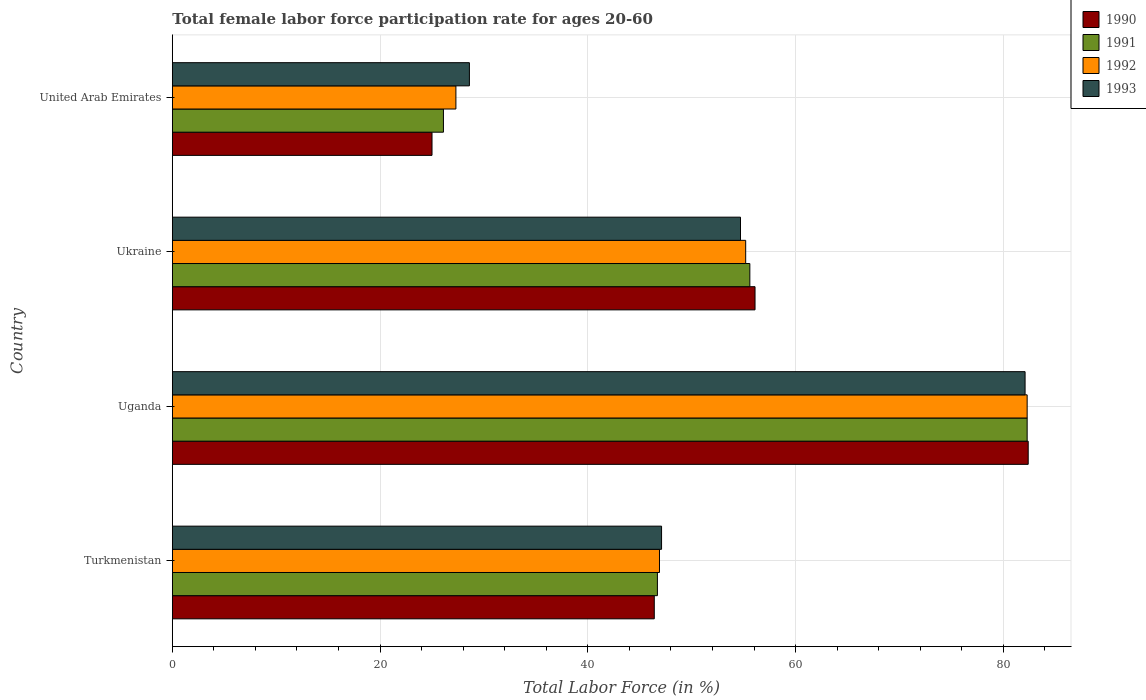How many groups of bars are there?
Make the answer very short. 4. Are the number of bars per tick equal to the number of legend labels?
Keep it short and to the point. Yes. Are the number of bars on each tick of the Y-axis equal?
Keep it short and to the point. Yes. What is the label of the 3rd group of bars from the top?
Offer a terse response. Uganda. What is the female labor force participation rate in 1992 in United Arab Emirates?
Give a very brief answer. 27.3. Across all countries, what is the maximum female labor force participation rate in 1992?
Make the answer very short. 82.3. In which country was the female labor force participation rate in 1991 maximum?
Offer a very short reply. Uganda. In which country was the female labor force participation rate in 1993 minimum?
Make the answer very short. United Arab Emirates. What is the total female labor force participation rate in 1990 in the graph?
Your answer should be very brief. 209.9. What is the difference between the female labor force participation rate in 1990 in Ukraine and that in United Arab Emirates?
Make the answer very short. 31.1. What is the difference between the female labor force participation rate in 1992 in Ukraine and the female labor force participation rate in 1991 in Uganda?
Your answer should be compact. -27.1. What is the average female labor force participation rate in 1993 per country?
Make the answer very short. 53.12. What is the difference between the female labor force participation rate in 1993 and female labor force participation rate in 1990 in Ukraine?
Provide a succinct answer. -1.4. What is the ratio of the female labor force participation rate in 1990 in Turkmenistan to that in Uganda?
Offer a very short reply. 0.56. Is the difference between the female labor force participation rate in 1993 in Ukraine and United Arab Emirates greater than the difference between the female labor force participation rate in 1990 in Ukraine and United Arab Emirates?
Offer a terse response. No. What is the difference between the highest and the second highest female labor force participation rate in 1991?
Offer a terse response. 26.7. What is the difference between the highest and the lowest female labor force participation rate in 1993?
Offer a very short reply. 53.5. In how many countries, is the female labor force participation rate in 1992 greater than the average female labor force participation rate in 1992 taken over all countries?
Offer a very short reply. 2. Is it the case that in every country, the sum of the female labor force participation rate in 1992 and female labor force participation rate in 1991 is greater than the female labor force participation rate in 1993?
Provide a succinct answer. Yes. How many bars are there?
Make the answer very short. 16. Are all the bars in the graph horizontal?
Your answer should be very brief. Yes. How many countries are there in the graph?
Your response must be concise. 4. Are the values on the major ticks of X-axis written in scientific E-notation?
Your answer should be compact. No. Does the graph contain any zero values?
Provide a short and direct response. No. Does the graph contain grids?
Your answer should be compact. Yes. How many legend labels are there?
Offer a terse response. 4. What is the title of the graph?
Your answer should be very brief. Total female labor force participation rate for ages 20-60. What is the label or title of the X-axis?
Provide a succinct answer. Total Labor Force (in %). What is the Total Labor Force (in %) in 1990 in Turkmenistan?
Your answer should be compact. 46.4. What is the Total Labor Force (in %) of 1991 in Turkmenistan?
Your response must be concise. 46.7. What is the Total Labor Force (in %) in 1992 in Turkmenistan?
Your response must be concise. 46.9. What is the Total Labor Force (in %) in 1993 in Turkmenistan?
Provide a succinct answer. 47.1. What is the Total Labor Force (in %) in 1990 in Uganda?
Provide a succinct answer. 82.4. What is the Total Labor Force (in %) of 1991 in Uganda?
Your response must be concise. 82.3. What is the Total Labor Force (in %) of 1992 in Uganda?
Give a very brief answer. 82.3. What is the Total Labor Force (in %) of 1993 in Uganda?
Provide a short and direct response. 82.1. What is the Total Labor Force (in %) of 1990 in Ukraine?
Your answer should be compact. 56.1. What is the Total Labor Force (in %) of 1991 in Ukraine?
Your answer should be very brief. 55.6. What is the Total Labor Force (in %) in 1992 in Ukraine?
Offer a very short reply. 55.2. What is the Total Labor Force (in %) in 1993 in Ukraine?
Ensure brevity in your answer.  54.7. What is the Total Labor Force (in %) of 1990 in United Arab Emirates?
Ensure brevity in your answer.  25. What is the Total Labor Force (in %) of 1991 in United Arab Emirates?
Ensure brevity in your answer.  26.1. What is the Total Labor Force (in %) in 1992 in United Arab Emirates?
Provide a short and direct response. 27.3. What is the Total Labor Force (in %) in 1993 in United Arab Emirates?
Provide a succinct answer. 28.6. Across all countries, what is the maximum Total Labor Force (in %) of 1990?
Keep it short and to the point. 82.4. Across all countries, what is the maximum Total Labor Force (in %) of 1991?
Offer a terse response. 82.3. Across all countries, what is the maximum Total Labor Force (in %) of 1992?
Your answer should be compact. 82.3. Across all countries, what is the maximum Total Labor Force (in %) of 1993?
Provide a succinct answer. 82.1. Across all countries, what is the minimum Total Labor Force (in %) of 1990?
Make the answer very short. 25. Across all countries, what is the minimum Total Labor Force (in %) of 1991?
Make the answer very short. 26.1. Across all countries, what is the minimum Total Labor Force (in %) in 1992?
Make the answer very short. 27.3. Across all countries, what is the minimum Total Labor Force (in %) in 1993?
Offer a very short reply. 28.6. What is the total Total Labor Force (in %) of 1990 in the graph?
Your response must be concise. 209.9. What is the total Total Labor Force (in %) in 1991 in the graph?
Give a very brief answer. 210.7. What is the total Total Labor Force (in %) in 1992 in the graph?
Offer a very short reply. 211.7. What is the total Total Labor Force (in %) of 1993 in the graph?
Your answer should be compact. 212.5. What is the difference between the Total Labor Force (in %) in 1990 in Turkmenistan and that in Uganda?
Keep it short and to the point. -36. What is the difference between the Total Labor Force (in %) of 1991 in Turkmenistan and that in Uganda?
Your answer should be very brief. -35.6. What is the difference between the Total Labor Force (in %) of 1992 in Turkmenistan and that in Uganda?
Your response must be concise. -35.4. What is the difference between the Total Labor Force (in %) in 1993 in Turkmenistan and that in Uganda?
Offer a very short reply. -35. What is the difference between the Total Labor Force (in %) of 1990 in Turkmenistan and that in Ukraine?
Keep it short and to the point. -9.7. What is the difference between the Total Labor Force (in %) in 1992 in Turkmenistan and that in Ukraine?
Ensure brevity in your answer.  -8.3. What is the difference between the Total Labor Force (in %) of 1993 in Turkmenistan and that in Ukraine?
Offer a terse response. -7.6. What is the difference between the Total Labor Force (in %) in 1990 in Turkmenistan and that in United Arab Emirates?
Ensure brevity in your answer.  21.4. What is the difference between the Total Labor Force (in %) in 1991 in Turkmenistan and that in United Arab Emirates?
Offer a very short reply. 20.6. What is the difference between the Total Labor Force (in %) in 1992 in Turkmenistan and that in United Arab Emirates?
Make the answer very short. 19.6. What is the difference between the Total Labor Force (in %) in 1993 in Turkmenistan and that in United Arab Emirates?
Provide a short and direct response. 18.5. What is the difference between the Total Labor Force (in %) of 1990 in Uganda and that in Ukraine?
Your answer should be compact. 26.3. What is the difference between the Total Labor Force (in %) in 1991 in Uganda and that in Ukraine?
Your answer should be compact. 26.7. What is the difference between the Total Labor Force (in %) in 1992 in Uganda and that in Ukraine?
Provide a short and direct response. 27.1. What is the difference between the Total Labor Force (in %) of 1993 in Uganda and that in Ukraine?
Your response must be concise. 27.4. What is the difference between the Total Labor Force (in %) in 1990 in Uganda and that in United Arab Emirates?
Your response must be concise. 57.4. What is the difference between the Total Labor Force (in %) in 1991 in Uganda and that in United Arab Emirates?
Offer a terse response. 56.2. What is the difference between the Total Labor Force (in %) in 1992 in Uganda and that in United Arab Emirates?
Offer a very short reply. 55. What is the difference between the Total Labor Force (in %) in 1993 in Uganda and that in United Arab Emirates?
Offer a terse response. 53.5. What is the difference between the Total Labor Force (in %) of 1990 in Ukraine and that in United Arab Emirates?
Provide a succinct answer. 31.1. What is the difference between the Total Labor Force (in %) in 1991 in Ukraine and that in United Arab Emirates?
Give a very brief answer. 29.5. What is the difference between the Total Labor Force (in %) in 1992 in Ukraine and that in United Arab Emirates?
Ensure brevity in your answer.  27.9. What is the difference between the Total Labor Force (in %) in 1993 in Ukraine and that in United Arab Emirates?
Your response must be concise. 26.1. What is the difference between the Total Labor Force (in %) in 1990 in Turkmenistan and the Total Labor Force (in %) in 1991 in Uganda?
Keep it short and to the point. -35.9. What is the difference between the Total Labor Force (in %) of 1990 in Turkmenistan and the Total Labor Force (in %) of 1992 in Uganda?
Make the answer very short. -35.9. What is the difference between the Total Labor Force (in %) of 1990 in Turkmenistan and the Total Labor Force (in %) of 1993 in Uganda?
Make the answer very short. -35.7. What is the difference between the Total Labor Force (in %) in 1991 in Turkmenistan and the Total Labor Force (in %) in 1992 in Uganda?
Your answer should be very brief. -35.6. What is the difference between the Total Labor Force (in %) in 1991 in Turkmenistan and the Total Labor Force (in %) in 1993 in Uganda?
Keep it short and to the point. -35.4. What is the difference between the Total Labor Force (in %) of 1992 in Turkmenistan and the Total Labor Force (in %) of 1993 in Uganda?
Provide a succinct answer. -35.2. What is the difference between the Total Labor Force (in %) of 1990 in Turkmenistan and the Total Labor Force (in %) of 1991 in Ukraine?
Offer a terse response. -9.2. What is the difference between the Total Labor Force (in %) of 1990 in Turkmenistan and the Total Labor Force (in %) of 1992 in Ukraine?
Your answer should be very brief. -8.8. What is the difference between the Total Labor Force (in %) in 1990 in Turkmenistan and the Total Labor Force (in %) in 1993 in Ukraine?
Offer a terse response. -8.3. What is the difference between the Total Labor Force (in %) of 1991 in Turkmenistan and the Total Labor Force (in %) of 1993 in Ukraine?
Provide a succinct answer. -8. What is the difference between the Total Labor Force (in %) in 1990 in Turkmenistan and the Total Labor Force (in %) in 1991 in United Arab Emirates?
Ensure brevity in your answer.  20.3. What is the difference between the Total Labor Force (in %) of 1990 in Turkmenistan and the Total Labor Force (in %) of 1992 in United Arab Emirates?
Your response must be concise. 19.1. What is the difference between the Total Labor Force (in %) in 1990 in Turkmenistan and the Total Labor Force (in %) in 1993 in United Arab Emirates?
Provide a succinct answer. 17.8. What is the difference between the Total Labor Force (in %) of 1992 in Turkmenistan and the Total Labor Force (in %) of 1993 in United Arab Emirates?
Offer a terse response. 18.3. What is the difference between the Total Labor Force (in %) of 1990 in Uganda and the Total Labor Force (in %) of 1991 in Ukraine?
Your answer should be compact. 26.8. What is the difference between the Total Labor Force (in %) in 1990 in Uganda and the Total Labor Force (in %) in 1992 in Ukraine?
Keep it short and to the point. 27.2. What is the difference between the Total Labor Force (in %) in 1990 in Uganda and the Total Labor Force (in %) in 1993 in Ukraine?
Your answer should be compact. 27.7. What is the difference between the Total Labor Force (in %) in 1991 in Uganda and the Total Labor Force (in %) in 1992 in Ukraine?
Provide a short and direct response. 27.1. What is the difference between the Total Labor Force (in %) in 1991 in Uganda and the Total Labor Force (in %) in 1993 in Ukraine?
Give a very brief answer. 27.6. What is the difference between the Total Labor Force (in %) of 1992 in Uganda and the Total Labor Force (in %) of 1993 in Ukraine?
Provide a succinct answer. 27.6. What is the difference between the Total Labor Force (in %) in 1990 in Uganda and the Total Labor Force (in %) in 1991 in United Arab Emirates?
Give a very brief answer. 56.3. What is the difference between the Total Labor Force (in %) in 1990 in Uganda and the Total Labor Force (in %) in 1992 in United Arab Emirates?
Give a very brief answer. 55.1. What is the difference between the Total Labor Force (in %) in 1990 in Uganda and the Total Labor Force (in %) in 1993 in United Arab Emirates?
Your response must be concise. 53.8. What is the difference between the Total Labor Force (in %) of 1991 in Uganda and the Total Labor Force (in %) of 1993 in United Arab Emirates?
Keep it short and to the point. 53.7. What is the difference between the Total Labor Force (in %) in 1992 in Uganda and the Total Labor Force (in %) in 1993 in United Arab Emirates?
Your response must be concise. 53.7. What is the difference between the Total Labor Force (in %) in 1990 in Ukraine and the Total Labor Force (in %) in 1991 in United Arab Emirates?
Keep it short and to the point. 30. What is the difference between the Total Labor Force (in %) in 1990 in Ukraine and the Total Labor Force (in %) in 1992 in United Arab Emirates?
Keep it short and to the point. 28.8. What is the difference between the Total Labor Force (in %) of 1991 in Ukraine and the Total Labor Force (in %) of 1992 in United Arab Emirates?
Make the answer very short. 28.3. What is the difference between the Total Labor Force (in %) in 1991 in Ukraine and the Total Labor Force (in %) in 1993 in United Arab Emirates?
Offer a terse response. 27. What is the difference between the Total Labor Force (in %) in 1992 in Ukraine and the Total Labor Force (in %) in 1993 in United Arab Emirates?
Offer a terse response. 26.6. What is the average Total Labor Force (in %) in 1990 per country?
Make the answer very short. 52.48. What is the average Total Labor Force (in %) in 1991 per country?
Your answer should be compact. 52.67. What is the average Total Labor Force (in %) in 1992 per country?
Provide a succinct answer. 52.92. What is the average Total Labor Force (in %) of 1993 per country?
Your response must be concise. 53.12. What is the difference between the Total Labor Force (in %) in 1992 and Total Labor Force (in %) in 1993 in Turkmenistan?
Give a very brief answer. -0.2. What is the difference between the Total Labor Force (in %) in 1990 and Total Labor Force (in %) in 1992 in Uganda?
Ensure brevity in your answer.  0.1. What is the difference between the Total Labor Force (in %) of 1990 and Total Labor Force (in %) of 1993 in Uganda?
Provide a succinct answer. 0.3. What is the difference between the Total Labor Force (in %) of 1991 and Total Labor Force (in %) of 1992 in Uganda?
Your answer should be compact. 0. What is the difference between the Total Labor Force (in %) in 1992 and Total Labor Force (in %) in 1993 in Uganda?
Your answer should be compact. 0.2. What is the difference between the Total Labor Force (in %) of 1990 and Total Labor Force (in %) of 1993 in Ukraine?
Offer a terse response. 1.4. What is the difference between the Total Labor Force (in %) of 1991 and Total Labor Force (in %) of 1993 in Ukraine?
Offer a terse response. 0.9. What is the difference between the Total Labor Force (in %) of 1990 and Total Labor Force (in %) of 1993 in United Arab Emirates?
Keep it short and to the point. -3.6. What is the difference between the Total Labor Force (in %) in 1991 and Total Labor Force (in %) in 1992 in United Arab Emirates?
Offer a very short reply. -1.2. What is the ratio of the Total Labor Force (in %) in 1990 in Turkmenistan to that in Uganda?
Give a very brief answer. 0.56. What is the ratio of the Total Labor Force (in %) in 1991 in Turkmenistan to that in Uganda?
Provide a short and direct response. 0.57. What is the ratio of the Total Labor Force (in %) of 1992 in Turkmenistan to that in Uganda?
Keep it short and to the point. 0.57. What is the ratio of the Total Labor Force (in %) in 1993 in Turkmenistan to that in Uganda?
Your answer should be compact. 0.57. What is the ratio of the Total Labor Force (in %) of 1990 in Turkmenistan to that in Ukraine?
Offer a very short reply. 0.83. What is the ratio of the Total Labor Force (in %) in 1991 in Turkmenistan to that in Ukraine?
Provide a succinct answer. 0.84. What is the ratio of the Total Labor Force (in %) of 1992 in Turkmenistan to that in Ukraine?
Ensure brevity in your answer.  0.85. What is the ratio of the Total Labor Force (in %) of 1993 in Turkmenistan to that in Ukraine?
Ensure brevity in your answer.  0.86. What is the ratio of the Total Labor Force (in %) of 1990 in Turkmenistan to that in United Arab Emirates?
Make the answer very short. 1.86. What is the ratio of the Total Labor Force (in %) in 1991 in Turkmenistan to that in United Arab Emirates?
Provide a short and direct response. 1.79. What is the ratio of the Total Labor Force (in %) in 1992 in Turkmenistan to that in United Arab Emirates?
Your response must be concise. 1.72. What is the ratio of the Total Labor Force (in %) of 1993 in Turkmenistan to that in United Arab Emirates?
Provide a succinct answer. 1.65. What is the ratio of the Total Labor Force (in %) of 1990 in Uganda to that in Ukraine?
Your answer should be very brief. 1.47. What is the ratio of the Total Labor Force (in %) in 1991 in Uganda to that in Ukraine?
Your response must be concise. 1.48. What is the ratio of the Total Labor Force (in %) in 1992 in Uganda to that in Ukraine?
Your response must be concise. 1.49. What is the ratio of the Total Labor Force (in %) in 1993 in Uganda to that in Ukraine?
Your response must be concise. 1.5. What is the ratio of the Total Labor Force (in %) of 1990 in Uganda to that in United Arab Emirates?
Offer a very short reply. 3.3. What is the ratio of the Total Labor Force (in %) of 1991 in Uganda to that in United Arab Emirates?
Give a very brief answer. 3.15. What is the ratio of the Total Labor Force (in %) in 1992 in Uganda to that in United Arab Emirates?
Provide a succinct answer. 3.01. What is the ratio of the Total Labor Force (in %) in 1993 in Uganda to that in United Arab Emirates?
Your response must be concise. 2.87. What is the ratio of the Total Labor Force (in %) in 1990 in Ukraine to that in United Arab Emirates?
Your answer should be compact. 2.24. What is the ratio of the Total Labor Force (in %) in 1991 in Ukraine to that in United Arab Emirates?
Provide a succinct answer. 2.13. What is the ratio of the Total Labor Force (in %) of 1992 in Ukraine to that in United Arab Emirates?
Keep it short and to the point. 2.02. What is the ratio of the Total Labor Force (in %) in 1993 in Ukraine to that in United Arab Emirates?
Provide a short and direct response. 1.91. What is the difference between the highest and the second highest Total Labor Force (in %) of 1990?
Offer a terse response. 26.3. What is the difference between the highest and the second highest Total Labor Force (in %) of 1991?
Offer a terse response. 26.7. What is the difference between the highest and the second highest Total Labor Force (in %) of 1992?
Provide a succinct answer. 27.1. What is the difference between the highest and the second highest Total Labor Force (in %) of 1993?
Your answer should be compact. 27.4. What is the difference between the highest and the lowest Total Labor Force (in %) of 1990?
Make the answer very short. 57.4. What is the difference between the highest and the lowest Total Labor Force (in %) in 1991?
Your answer should be compact. 56.2. What is the difference between the highest and the lowest Total Labor Force (in %) in 1992?
Your answer should be compact. 55. What is the difference between the highest and the lowest Total Labor Force (in %) of 1993?
Make the answer very short. 53.5. 